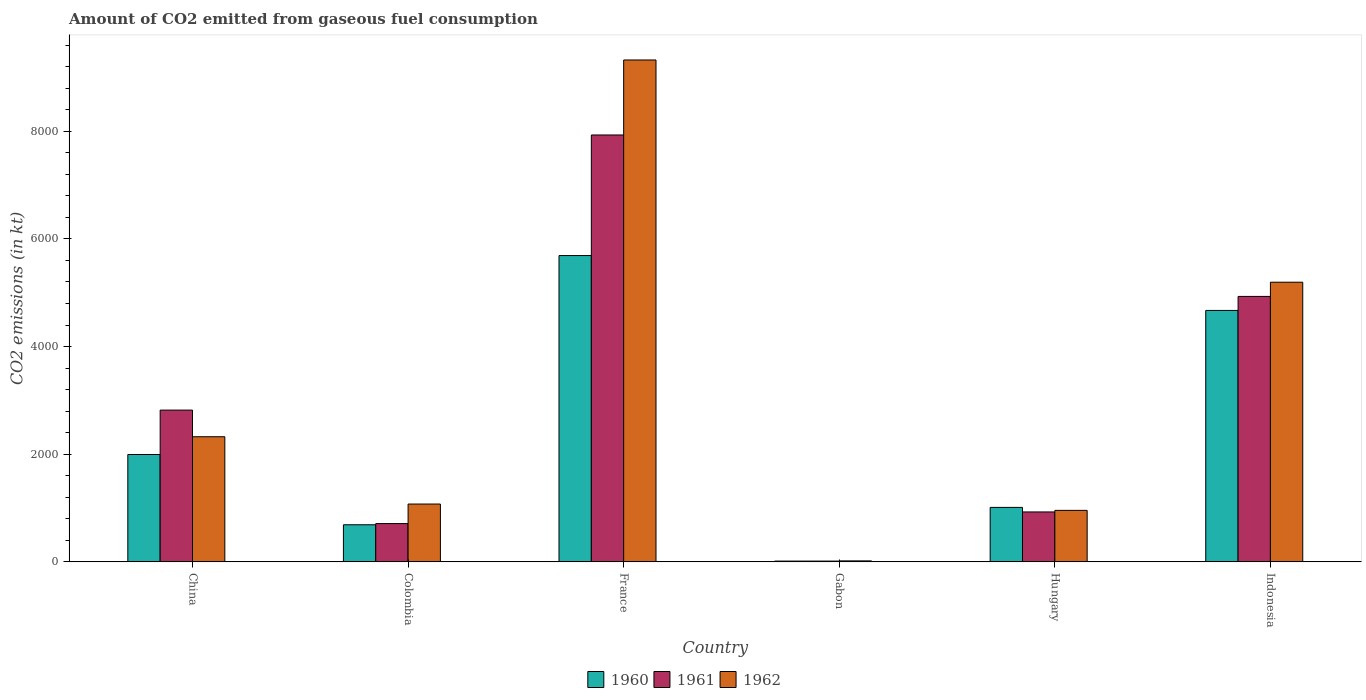How many different coloured bars are there?
Offer a terse response. 3. Are the number of bars on each tick of the X-axis equal?
Offer a terse response. Yes. How many bars are there on the 6th tick from the right?
Provide a succinct answer. 3. What is the amount of CO2 emitted in 1960 in Colombia?
Offer a very short reply. 689.4. Across all countries, what is the maximum amount of CO2 emitted in 1961?
Your answer should be very brief. 7931.72. Across all countries, what is the minimum amount of CO2 emitted in 1961?
Give a very brief answer. 14.67. In which country was the amount of CO2 emitted in 1961 maximum?
Ensure brevity in your answer.  France. In which country was the amount of CO2 emitted in 1961 minimum?
Provide a succinct answer. Gabon. What is the total amount of CO2 emitted in 1962 in the graph?
Your answer should be very brief. 1.89e+04. What is the difference between the amount of CO2 emitted in 1960 in Colombia and that in Indonesia?
Give a very brief answer. -3982.36. What is the difference between the amount of CO2 emitted in 1961 in Gabon and the amount of CO2 emitted in 1960 in France?
Your answer should be compact. -5676.52. What is the average amount of CO2 emitted in 1961 per country?
Give a very brief answer. 2889.6. What is the difference between the amount of CO2 emitted of/in 1960 and amount of CO2 emitted of/in 1962 in France?
Your answer should be compact. -3634. What is the ratio of the amount of CO2 emitted in 1962 in Gabon to that in Indonesia?
Make the answer very short. 0. What is the difference between the highest and the second highest amount of CO2 emitted in 1960?
Provide a succinct answer. -3696.34. What is the difference between the highest and the lowest amount of CO2 emitted in 1962?
Provide a short and direct response. 9306.85. Is it the case that in every country, the sum of the amount of CO2 emitted in 1961 and amount of CO2 emitted in 1962 is greater than the amount of CO2 emitted in 1960?
Make the answer very short. Yes. How many countries are there in the graph?
Keep it short and to the point. 6. What is the difference between two consecutive major ticks on the Y-axis?
Provide a short and direct response. 2000. Are the values on the major ticks of Y-axis written in scientific E-notation?
Provide a succinct answer. No. Does the graph contain any zero values?
Provide a short and direct response. No. Does the graph contain grids?
Ensure brevity in your answer.  No. What is the title of the graph?
Make the answer very short. Amount of CO2 emitted from gaseous fuel consumption. Does "2004" appear as one of the legend labels in the graph?
Make the answer very short. No. What is the label or title of the Y-axis?
Your answer should be very brief. CO2 emissions (in kt). What is the CO2 emissions (in kt) in 1960 in China?
Your answer should be very brief. 1994.85. What is the CO2 emissions (in kt) of 1961 in China?
Make the answer very short. 2819.92. What is the CO2 emissions (in kt) in 1962 in China?
Ensure brevity in your answer.  2324.88. What is the CO2 emissions (in kt) of 1960 in Colombia?
Your answer should be compact. 689.4. What is the CO2 emissions (in kt) of 1961 in Colombia?
Give a very brief answer. 711.4. What is the CO2 emissions (in kt) in 1962 in Colombia?
Provide a short and direct response. 1074.43. What is the CO2 emissions (in kt) of 1960 in France?
Your answer should be very brief. 5691.18. What is the CO2 emissions (in kt) in 1961 in France?
Offer a terse response. 7931.72. What is the CO2 emissions (in kt) of 1962 in France?
Your answer should be very brief. 9325.18. What is the CO2 emissions (in kt) in 1960 in Gabon?
Your answer should be compact. 14.67. What is the CO2 emissions (in kt) of 1961 in Gabon?
Provide a short and direct response. 14.67. What is the CO2 emissions (in kt) in 1962 in Gabon?
Offer a very short reply. 18.34. What is the CO2 emissions (in kt) in 1960 in Hungary?
Offer a terse response. 1012.09. What is the CO2 emissions (in kt) in 1961 in Hungary?
Your answer should be compact. 927.75. What is the CO2 emissions (in kt) of 1962 in Hungary?
Offer a terse response. 957.09. What is the CO2 emissions (in kt) in 1960 in Indonesia?
Provide a succinct answer. 4671.76. What is the CO2 emissions (in kt) in 1961 in Indonesia?
Keep it short and to the point. 4932.11. What is the CO2 emissions (in kt) in 1962 in Indonesia?
Provide a succinct answer. 5196.14. Across all countries, what is the maximum CO2 emissions (in kt) of 1960?
Offer a terse response. 5691.18. Across all countries, what is the maximum CO2 emissions (in kt) in 1961?
Provide a short and direct response. 7931.72. Across all countries, what is the maximum CO2 emissions (in kt) in 1962?
Provide a succinct answer. 9325.18. Across all countries, what is the minimum CO2 emissions (in kt) of 1960?
Your answer should be compact. 14.67. Across all countries, what is the minimum CO2 emissions (in kt) of 1961?
Your answer should be very brief. 14.67. Across all countries, what is the minimum CO2 emissions (in kt) of 1962?
Provide a short and direct response. 18.34. What is the total CO2 emissions (in kt) of 1960 in the graph?
Ensure brevity in your answer.  1.41e+04. What is the total CO2 emissions (in kt) in 1961 in the graph?
Keep it short and to the point. 1.73e+04. What is the total CO2 emissions (in kt) of 1962 in the graph?
Make the answer very short. 1.89e+04. What is the difference between the CO2 emissions (in kt) in 1960 in China and that in Colombia?
Give a very brief answer. 1305.45. What is the difference between the CO2 emissions (in kt) of 1961 in China and that in Colombia?
Provide a short and direct response. 2108.53. What is the difference between the CO2 emissions (in kt) in 1962 in China and that in Colombia?
Your answer should be very brief. 1250.45. What is the difference between the CO2 emissions (in kt) of 1960 in China and that in France?
Provide a succinct answer. -3696.34. What is the difference between the CO2 emissions (in kt) in 1961 in China and that in France?
Give a very brief answer. -5111.8. What is the difference between the CO2 emissions (in kt) in 1962 in China and that in France?
Make the answer very short. -7000.3. What is the difference between the CO2 emissions (in kt) of 1960 in China and that in Gabon?
Offer a very short reply. 1980.18. What is the difference between the CO2 emissions (in kt) of 1961 in China and that in Gabon?
Offer a very short reply. 2805.26. What is the difference between the CO2 emissions (in kt) of 1962 in China and that in Gabon?
Provide a succinct answer. 2306.54. What is the difference between the CO2 emissions (in kt) in 1960 in China and that in Hungary?
Your answer should be compact. 982.76. What is the difference between the CO2 emissions (in kt) in 1961 in China and that in Hungary?
Ensure brevity in your answer.  1892.17. What is the difference between the CO2 emissions (in kt) of 1962 in China and that in Hungary?
Ensure brevity in your answer.  1367.79. What is the difference between the CO2 emissions (in kt) in 1960 in China and that in Indonesia?
Offer a very short reply. -2676.91. What is the difference between the CO2 emissions (in kt) in 1961 in China and that in Indonesia?
Offer a terse response. -2112.19. What is the difference between the CO2 emissions (in kt) in 1962 in China and that in Indonesia?
Keep it short and to the point. -2871.26. What is the difference between the CO2 emissions (in kt) in 1960 in Colombia and that in France?
Provide a succinct answer. -5001.79. What is the difference between the CO2 emissions (in kt) of 1961 in Colombia and that in France?
Your answer should be compact. -7220.32. What is the difference between the CO2 emissions (in kt) in 1962 in Colombia and that in France?
Your response must be concise. -8250.75. What is the difference between the CO2 emissions (in kt) in 1960 in Colombia and that in Gabon?
Offer a terse response. 674.73. What is the difference between the CO2 emissions (in kt) of 1961 in Colombia and that in Gabon?
Keep it short and to the point. 696.73. What is the difference between the CO2 emissions (in kt) of 1962 in Colombia and that in Gabon?
Make the answer very short. 1056.1. What is the difference between the CO2 emissions (in kt) of 1960 in Colombia and that in Hungary?
Offer a very short reply. -322.7. What is the difference between the CO2 emissions (in kt) in 1961 in Colombia and that in Hungary?
Make the answer very short. -216.35. What is the difference between the CO2 emissions (in kt) of 1962 in Colombia and that in Hungary?
Your answer should be very brief. 117.34. What is the difference between the CO2 emissions (in kt) of 1960 in Colombia and that in Indonesia?
Offer a very short reply. -3982.36. What is the difference between the CO2 emissions (in kt) of 1961 in Colombia and that in Indonesia?
Provide a succinct answer. -4220.72. What is the difference between the CO2 emissions (in kt) in 1962 in Colombia and that in Indonesia?
Provide a succinct answer. -4121.71. What is the difference between the CO2 emissions (in kt) in 1960 in France and that in Gabon?
Your answer should be very brief. 5676.52. What is the difference between the CO2 emissions (in kt) in 1961 in France and that in Gabon?
Provide a succinct answer. 7917.05. What is the difference between the CO2 emissions (in kt) in 1962 in France and that in Gabon?
Keep it short and to the point. 9306.85. What is the difference between the CO2 emissions (in kt) of 1960 in France and that in Hungary?
Offer a terse response. 4679.09. What is the difference between the CO2 emissions (in kt) in 1961 in France and that in Hungary?
Offer a very short reply. 7003.97. What is the difference between the CO2 emissions (in kt) of 1962 in France and that in Hungary?
Your answer should be very brief. 8368.09. What is the difference between the CO2 emissions (in kt) in 1960 in France and that in Indonesia?
Your response must be concise. 1019.43. What is the difference between the CO2 emissions (in kt) in 1961 in France and that in Indonesia?
Make the answer very short. 2999.61. What is the difference between the CO2 emissions (in kt) of 1962 in France and that in Indonesia?
Your answer should be compact. 4129.04. What is the difference between the CO2 emissions (in kt) of 1960 in Gabon and that in Hungary?
Keep it short and to the point. -997.42. What is the difference between the CO2 emissions (in kt) in 1961 in Gabon and that in Hungary?
Give a very brief answer. -913.08. What is the difference between the CO2 emissions (in kt) in 1962 in Gabon and that in Hungary?
Your answer should be very brief. -938.75. What is the difference between the CO2 emissions (in kt) of 1960 in Gabon and that in Indonesia?
Ensure brevity in your answer.  -4657.09. What is the difference between the CO2 emissions (in kt) in 1961 in Gabon and that in Indonesia?
Offer a very short reply. -4917.45. What is the difference between the CO2 emissions (in kt) of 1962 in Gabon and that in Indonesia?
Your answer should be compact. -5177.8. What is the difference between the CO2 emissions (in kt) in 1960 in Hungary and that in Indonesia?
Keep it short and to the point. -3659.67. What is the difference between the CO2 emissions (in kt) in 1961 in Hungary and that in Indonesia?
Your response must be concise. -4004.36. What is the difference between the CO2 emissions (in kt) in 1962 in Hungary and that in Indonesia?
Keep it short and to the point. -4239.05. What is the difference between the CO2 emissions (in kt) in 1960 in China and the CO2 emissions (in kt) in 1961 in Colombia?
Your answer should be compact. 1283.45. What is the difference between the CO2 emissions (in kt) in 1960 in China and the CO2 emissions (in kt) in 1962 in Colombia?
Ensure brevity in your answer.  920.42. What is the difference between the CO2 emissions (in kt) in 1961 in China and the CO2 emissions (in kt) in 1962 in Colombia?
Keep it short and to the point. 1745.49. What is the difference between the CO2 emissions (in kt) in 1960 in China and the CO2 emissions (in kt) in 1961 in France?
Provide a short and direct response. -5936.87. What is the difference between the CO2 emissions (in kt) of 1960 in China and the CO2 emissions (in kt) of 1962 in France?
Keep it short and to the point. -7330.33. What is the difference between the CO2 emissions (in kt) of 1961 in China and the CO2 emissions (in kt) of 1962 in France?
Offer a terse response. -6505.26. What is the difference between the CO2 emissions (in kt) in 1960 in China and the CO2 emissions (in kt) in 1961 in Gabon?
Keep it short and to the point. 1980.18. What is the difference between the CO2 emissions (in kt) in 1960 in China and the CO2 emissions (in kt) in 1962 in Gabon?
Your answer should be compact. 1976.51. What is the difference between the CO2 emissions (in kt) of 1961 in China and the CO2 emissions (in kt) of 1962 in Gabon?
Offer a very short reply. 2801.59. What is the difference between the CO2 emissions (in kt) in 1960 in China and the CO2 emissions (in kt) in 1961 in Hungary?
Keep it short and to the point. 1067.1. What is the difference between the CO2 emissions (in kt) of 1960 in China and the CO2 emissions (in kt) of 1962 in Hungary?
Offer a terse response. 1037.76. What is the difference between the CO2 emissions (in kt) in 1961 in China and the CO2 emissions (in kt) in 1962 in Hungary?
Keep it short and to the point. 1862.84. What is the difference between the CO2 emissions (in kt) of 1960 in China and the CO2 emissions (in kt) of 1961 in Indonesia?
Your answer should be compact. -2937.27. What is the difference between the CO2 emissions (in kt) of 1960 in China and the CO2 emissions (in kt) of 1962 in Indonesia?
Your answer should be compact. -3201.29. What is the difference between the CO2 emissions (in kt) of 1961 in China and the CO2 emissions (in kt) of 1962 in Indonesia?
Ensure brevity in your answer.  -2376.22. What is the difference between the CO2 emissions (in kt) of 1960 in Colombia and the CO2 emissions (in kt) of 1961 in France?
Give a very brief answer. -7242.32. What is the difference between the CO2 emissions (in kt) of 1960 in Colombia and the CO2 emissions (in kt) of 1962 in France?
Ensure brevity in your answer.  -8635.78. What is the difference between the CO2 emissions (in kt) of 1961 in Colombia and the CO2 emissions (in kt) of 1962 in France?
Offer a terse response. -8613.78. What is the difference between the CO2 emissions (in kt) of 1960 in Colombia and the CO2 emissions (in kt) of 1961 in Gabon?
Provide a short and direct response. 674.73. What is the difference between the CO2 emissions (in kt) in 1960 in Colombia and the CO2 emissions (in kt) in 1962 in Gabon?
Your answer should be compact. 671.06. What is the difference between the CO2 emissions (in kt) of 1961 in Colombia and the CO2 emissions (in kt) of 1962 in Gabon?
Your answer should be very brief. 693.06. What is the difference between the CO2 emissions (in kt) of 1960 in Colombia and the CO2 emissions (in kt) of 1961 in Hungary?
Your response must be concise. -238.35. What is the difference between the CO2 emissions (in kt) in 1960 in Colombia and the CO2 emissions (in kt) in 1962 in Hungary?
Offer a very short reply. -267.69. What is the difference between the CO2 emissions (in kt) in 1961 in Colombia and the CO2 emissions (in kt) in 1962 in Hungary?
Make the answer very short. -245.69. What is the difference between the CO2 emissions (in kt) in 1960 in Colombia and the CO2 emissions (in kt) in 1961 in Indonesia?
Your answer should be very brief. -4242.72. What is the difference between the CO2 emissions (in kt) of 1960 in Colombia and the CO2 emissions (in kt) of 1962 in Indonesia?
Make the answer very short. -4506.74. What is the difference between the CO2 emissions (in kt) of 1961 in Colombia and the CO2 emissions (in kt) of 1962 in Indonesia?
Ensure brevity in your answer.  -4484.74. What is the difference between the CO2 emissions (in kt) in 1960 in France and the CO2 emissions (in kt) in 1961 in Gabon?
Keep it short and to the point. 5676.52. What is the difference between the CO2 emissions (in kt) in 1960 in France and the CO2 emissions (in kt) in 1962 in Gabon?
Your response must be concise. 5672.85. What is the difference between the CO2 emissions (in kt) of 1961 in France and the CO2 emissions (in kt) of 1962 in Gabon?
Provide a succinct answer. 7913.39. What is the difference between the CO2 emissions (in kt) of 1960 in France and the CO2 emissions (in kt) of 1961 in Hungary?
Offer a very short reply. 4763.43. What is the difference between the CO2 emissions (in kt) in 1960 in France and the CO2 emissions (in kt) in 1962 in Hungary?
Offer a terse response. 4734.1. What is the difference between the CO2 emissions (in kt) of 1961 in France and the CO2 emissions (in kt) of 1962 in Hungary?
Offer a terse response. 6974.63. What is the difference between the CO2 emissions (in kt) in 1960 in France and the CO2 emissions (in kt) in 1961 in Indonesia?
Offer a terse response. 759.07. What is the difference between the CO2 emissions (in kt) of 1960 in France and the CO2 emissions (in kt) of 1962 in Indonesia?
Offer a very short reply. 495.05. What is the difference between the CO2 emissions (in kt) of 1961 in France and the CO2 emissions (in kt) of 1962 in Indonesia?
Provide a short and direct response. 2735.58. What is the difference between the CO2 emissions (in kt) of 1960 in Gabon and the CO2 emissions (in kt) of 1961 in Hungary?
Make the answer very short. -913.08. What is the difference between the CO2 emissions (in kt) in 1960 in Gabon and the CO2 emissions (in kt) in 1962 in Hungary?
Your response must be concise. -942.42. What is the difference between the CO2 emissions (in kt) of 1961 in Gabon and the CO2 emissions (in kt) of 1962 in Hungary?
Make the answer very short. -942.42. What is the difference between the CO2 emissions (in kt) in 1960 in Gabon and the CO2 emissions (in kt) in 1961 in Indonesia?
Offer a terse response. -4917.45. What is the difference between the CO2 emissions (in kt) of 1960 in Gabon and the CO2 emissions (in kt) of 1962 in Indonesia?
Keep it short and to the point. -5181.47. What is the difference between the CO2 emissions (in kt) in 1961 in Gabon and the CO2 emissions (in kt) in 1962 in Indonesia?
Your response must be concise. -5181.47. What is the difference between the CO2 emissions (in kt) in 1960 in Hungary and the CO2 emissions (in kt) in 1961 in Indonesia?
Provide a succinct answer. -3920.02. What is the difference between the CO2 emissions (in kt) in 1960 in Hungary and the CO2 emissions (in kt) in 1962 in Indonesia?
Offer a very short reply. -4184.05. What is the difference between the CO2 emissions (in kt) in 1961 in Hungary and the CO2 emissions (in kt) in 1962 in Indonesia?
Ensure brevity in your answer.  -4268.39. What is the average CO2 emissions (in kt) in 1960 per country?
Your answer should be compact. 2345.66. What is the average CO2 emissions (in kt) of 1961 per country?
Provide a short and direct response. 2889.6. What is the average CO2 emissions (in kt) of 1962 per country?
Provide a short and direct response. 3149.34. What is the difference between the CO2 emissions (in kt) of 1960 and CO2 emissions (in kt) of 1961 in China?
Offer a terse response. -825.08. What is the difference between the CO2 emissions (in kt) in 1960 and CO2 emissions (in kt) in 1962 in China?
Offer a very short reply. -330.03. What is the difference between the CO2 emissions (in kt) of 1961 and CO2 emissions (in kt) of 1962 in China?
Your answer should be very brief. 495.05. What is the difference between the CO2 emissions (in kt) of 1960 and CO2 emissions (in kt) of 1961 in Colombia?
Your answer should be compact. -22. What is the difference between the CO2 emissions (in kt) in 1960 and CO2 emissions (in kt) in 1962 in Colombia?
Make the answer very short. -385.04. What is the difference between the CO2 emissions (in kt) of 1961 and CO2 emissions (in kt) of 1962 in Colombia?
Make the answer very short. -363.03. What is the difference between the CO2 emissions (in kt) of 1960 and CO2 emissions (in kt) of 1961 in France?
Your answer should be very brief. -2240.54. What is the difference between the CO2 emissions (in kt) of 1960 and CO2 emissions (in kt) of 1962 in France?
Your response must be concise. -3634. What is the difference between the CO2 emissions (in kt) in 1961 and CO2 emissions (in kt) in 1962 in France?
Keep it short and to the point. -1393.46. What is the difference between the CO2 emissions (in kt) of 1960 and CO2 emissions (in kt) of 1962 in Gabon?
Your response must be concise. -3.67. What is the difference between the CO2 emissions (in kt) in 1961 and CO2 emissions (in kt) in 1962 in Gabon?
Your response must be concise. -3.67. What is the difference between the CO2 emissions (in kt) in 1960 and CO2 emissions (in kt) in 1961 in Hungary?
Provide a short and direct response. 84.34. What is the difference between the CO2 emissions (in kt) of 1960 and CO2 emissions (in kt) of 1962 in Hungary?
Your answer should be compact. 55.01. What is the difference between the CO2 emissions (in kt) in 1961 and CO2 emissions (in kt) in 1962 in Hungary?
Ensure brevity in your answer.  -29.34. What is the difference between the CO2 emissions (in kt) of 1960 and CO2 emissions (in kt) of 1961 in Indonesia?
Keep it short and to the point. -260.36. What is the difference between the CO2 emissions (in kt) of 1960 and CO2 emissions (in kt) of 1962 in Indonesia?
Provide a short and direct response. -524.38. What is the difference between the CO2 emissions (in kt) of 1961 and CO2 emissions (in kt) of 1962 in Indonesia?
Ensure brevity in your answer.  -264.02. What is the ratio of the CO2 emissions (in kt) in 1960 in China to that in Colombia?
Provide a succinct answer. 2.89. What is the ratio of the CO2 emissions (in kt) in 1961 in China to that in Colombia?
Your answer should be very brief. 3.96. What is the ratio of the CO2 emissions (in kt) in 1962 in China to that in Colombia?
Your answer should be very brief. 2.16. What is the ratio of the CO2 emissions (in kt) in 1960 in China to that in France?
Give a very brief answer. 0.35. What is the ratio of the CO2 emissions (in kt) in 1961 in China to that in France?
Give a very brief answer. 0.36. What is the ratio of the CO2 emissions (in kt) in 1962 in China to that in France?
Your answer should be very brief. 0.25. What is the ratio of the CO2 emissions (in kt) in 1960 in China to that in Gabon?
Offer a terse response. 136. What is the ratio of the CO2 emissions (in kt) in 1961 in China to that in Gabon?
Your response must be concise. 192.25. What is the ratio of the CO2 emissions (in kt) in 1962 in China to that in Gabon?
Your answer should be very brief. 126.8. What is the ratio of the CO2 emissions (in kt) in 1960 in China to that in Hungary?
Make the answer very short. 1.97. What is the ratio of the CO2 emissions (in kt) of 1961 in China to that in Hungary?
Your answer should be very brief. 3.04. What is the ratio of the CO2 emissions (in kt) of 1962 in China to that in Hungary?
Offer a terse response. 2.43. What is the ratio of the CO2 emissions (in kt) of 1960 in China to that in Indonesia?
Offer a very short reply. 0.43. What is the ratio of the CO2 emissions (in kt) of 1961 in China to that in Indonesia?
Give a very brief answer. 0.57. What is the ratio of the CO2 emissions (in kt) in 1962 in China to that in Indonesia?
Your answer should be compact. 0.45. What is the ratio of the CO2 emissions (in kt) in 1960 in Colombia to that in France?
Ensure brevity in your answer.  0.12. What is the ratio of the CO2 emissions (in kt) of 1961 in Colombia to that in France?
Provide a succinct answer. 0.09. What is the ratio of the CO2 emissions (in kt) of 1962 in Colombia to that in France?
Give a very brief answer. 0.12. What is the ratio of the CO2 emissions (in kt) in 1961 in Colombia to that in Gabon?
Make the answer very short. 48.5. What is the ratio of the CO2 emissions (in kt) of 1962 in Colombia to that in Gabon?
Ensure brevity in your answer.  58.6. What is the ratio of the CO2 emissions (in kt) of 1960 in Colombia to that in Hungary?
Provide a succinct answer. 0.68. What is the ratio of the CO2 emissions (in kt) in 1961 in Colombia to that in Hungary?
Offer a terse response. 0.77. What is the ratio of the CO2 emissions (in kt) of 1962 in Colombia to that in Hungary?
Ensure brevity in your answer.  1.12. What is the ratio of the CO2 emissions (in kt) in 1960 in Colombia to that in Indonesia?
Give a very brief answer. 0.15. What is the ratio of the CO2 emissions (in kt) of 1961 in Colombia to that in Indonesia?
Provide a short and direct response. 0.14. What is the ratio of the CO2 emissions (in kt) of 1962 in Colombia to that in Indonesia?
Your answer should be compact. 0.21. What is the ratio of the CO2 emissions (in kt) in 1960 in France to that in Gabon?
Make the answer very short. 388. What is the ratio of the CO2 emissions (in kt) of 1961 in France to that in Gabon?
Offer a very short reply. 540.75. What is the ratio of the CO2 emissions (in kt) in 1962 in France to that in Gabon?
Give a very brief answer. 508.6. What is the ratio of the CO2 emissions (in kt) in 1960 in France to that in Hungary?
Keep it short and to the point. 5.62. What is the ratio of the CO2 emissions (in kt) of 1961 in France to that in Hungary?
Your answer should be compact. 8.55. What is the ratio of the CO2 emissions (in kt) of 1962 in France to that in Hungary?
Your response must be concise. 9.74. What is the ratio of the CO2 emissions (in kt) in 1960 in France to that in Indonesia?
Ensure brevity in your answer.  1.22. What is the ratio of the CO2 emissions (in kt) in 1961 in France to that in Indonesia?
Provide a succinct answer. 1.61. What is the ratio of the CO2 emissions (in kt) in 1962 in France to that in Indonesia?
Offer a very short reply. 1.79. What is the ratio of the CO2 emissions (in kt) of 1960 in Gabon to that in Hungary?
Your answer should be compact. 0.01. What is the ratio of the CO2 emissions (in kt) of 1961 in Gabon to that in Hungary?
Your answer should be very brief. 0.02. What is the ratio of the CO2 emissions (in kt) in 1962 in Gabon to that in Hungary?
Offer a very short reply. 0.02. What is the ratio of the CO2 emissions (in kt) in 1960 in Gabon to that in Indonesia?
Your answer should be compact. 0. What is the ratio of the CO2 emissions (in kt) of 1961 in Gabon to that in Indonesia?
Provide a succinct answer. 0. What is the ratio of the CO2 emissions (in kt) in 1962 in Gabon to that in Indonesia?
Give a very brief answer. 0. What is the ratio of the CO2 emissions (in kt) of 1960 in Hungary to that in Indonesia?
Offer a terse response. 0.22. What is the ratio of the CO2 emissions (in kt) in 1961 in Hungary to that in Indonesia?
Keep it short and to the point. 0.19. What is the ratio of the CO2 emissions (in kt) of 1962 in Hungary to that in Indonesia?
Provide a short and direct response. 0.18. What is the difference between the highest and the second highest CO2 emissions (in kt) of 1960?
Keep it short and to the point. 1019.43. What is the difference between the highest and the second highest CO2 emissions (in kt) of 1961?
Ensure brevity in your answer.  2999.61. What is the difference between the highest and the second highest CO2 emissions (in kt) of 1962?
Make the answer very short. 4129.04. What is the difference between the highest and the lowest CO2 emissions (in kt) of 1960?
Ensure brevity in your answer.  5676.52. What is the difference between the highest and the lowest CO2 emissions (in kt) in 1961?
Ensure brevity in your answer.  7917.05. What is the difference between the highest and the lowest CO2 emissions (in kt) in 1962?
Offer a terse response. 9306.85. 